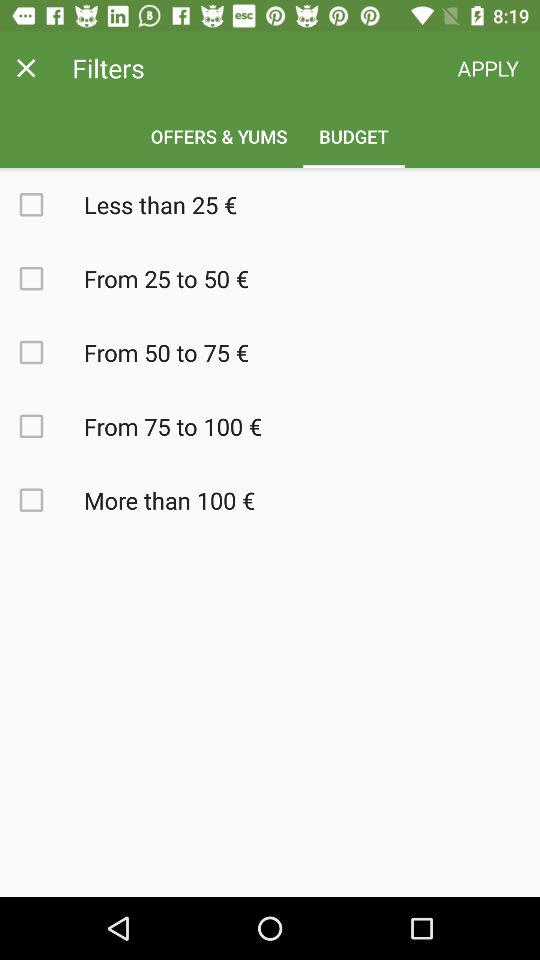How many price ranges are available?
Answer the question using a single word or phrase. 5 